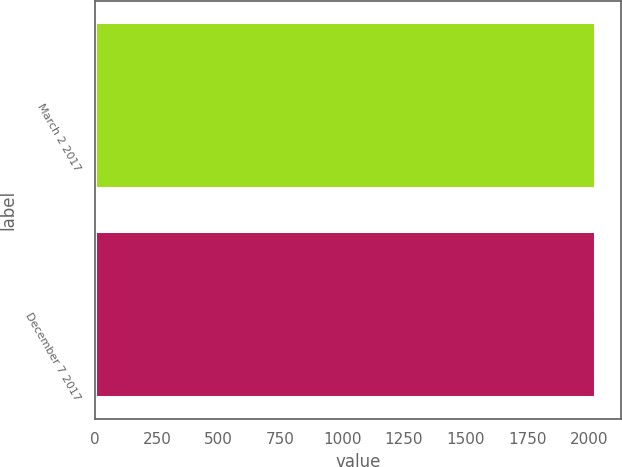Convert chart. <chart><loc_0><loc_0><loc_500><loc_500><bar_chart><fcel>March 2 2017<fcel>December 7 2017<nl><fcel>2027<fcel>2028<nl></chart> 